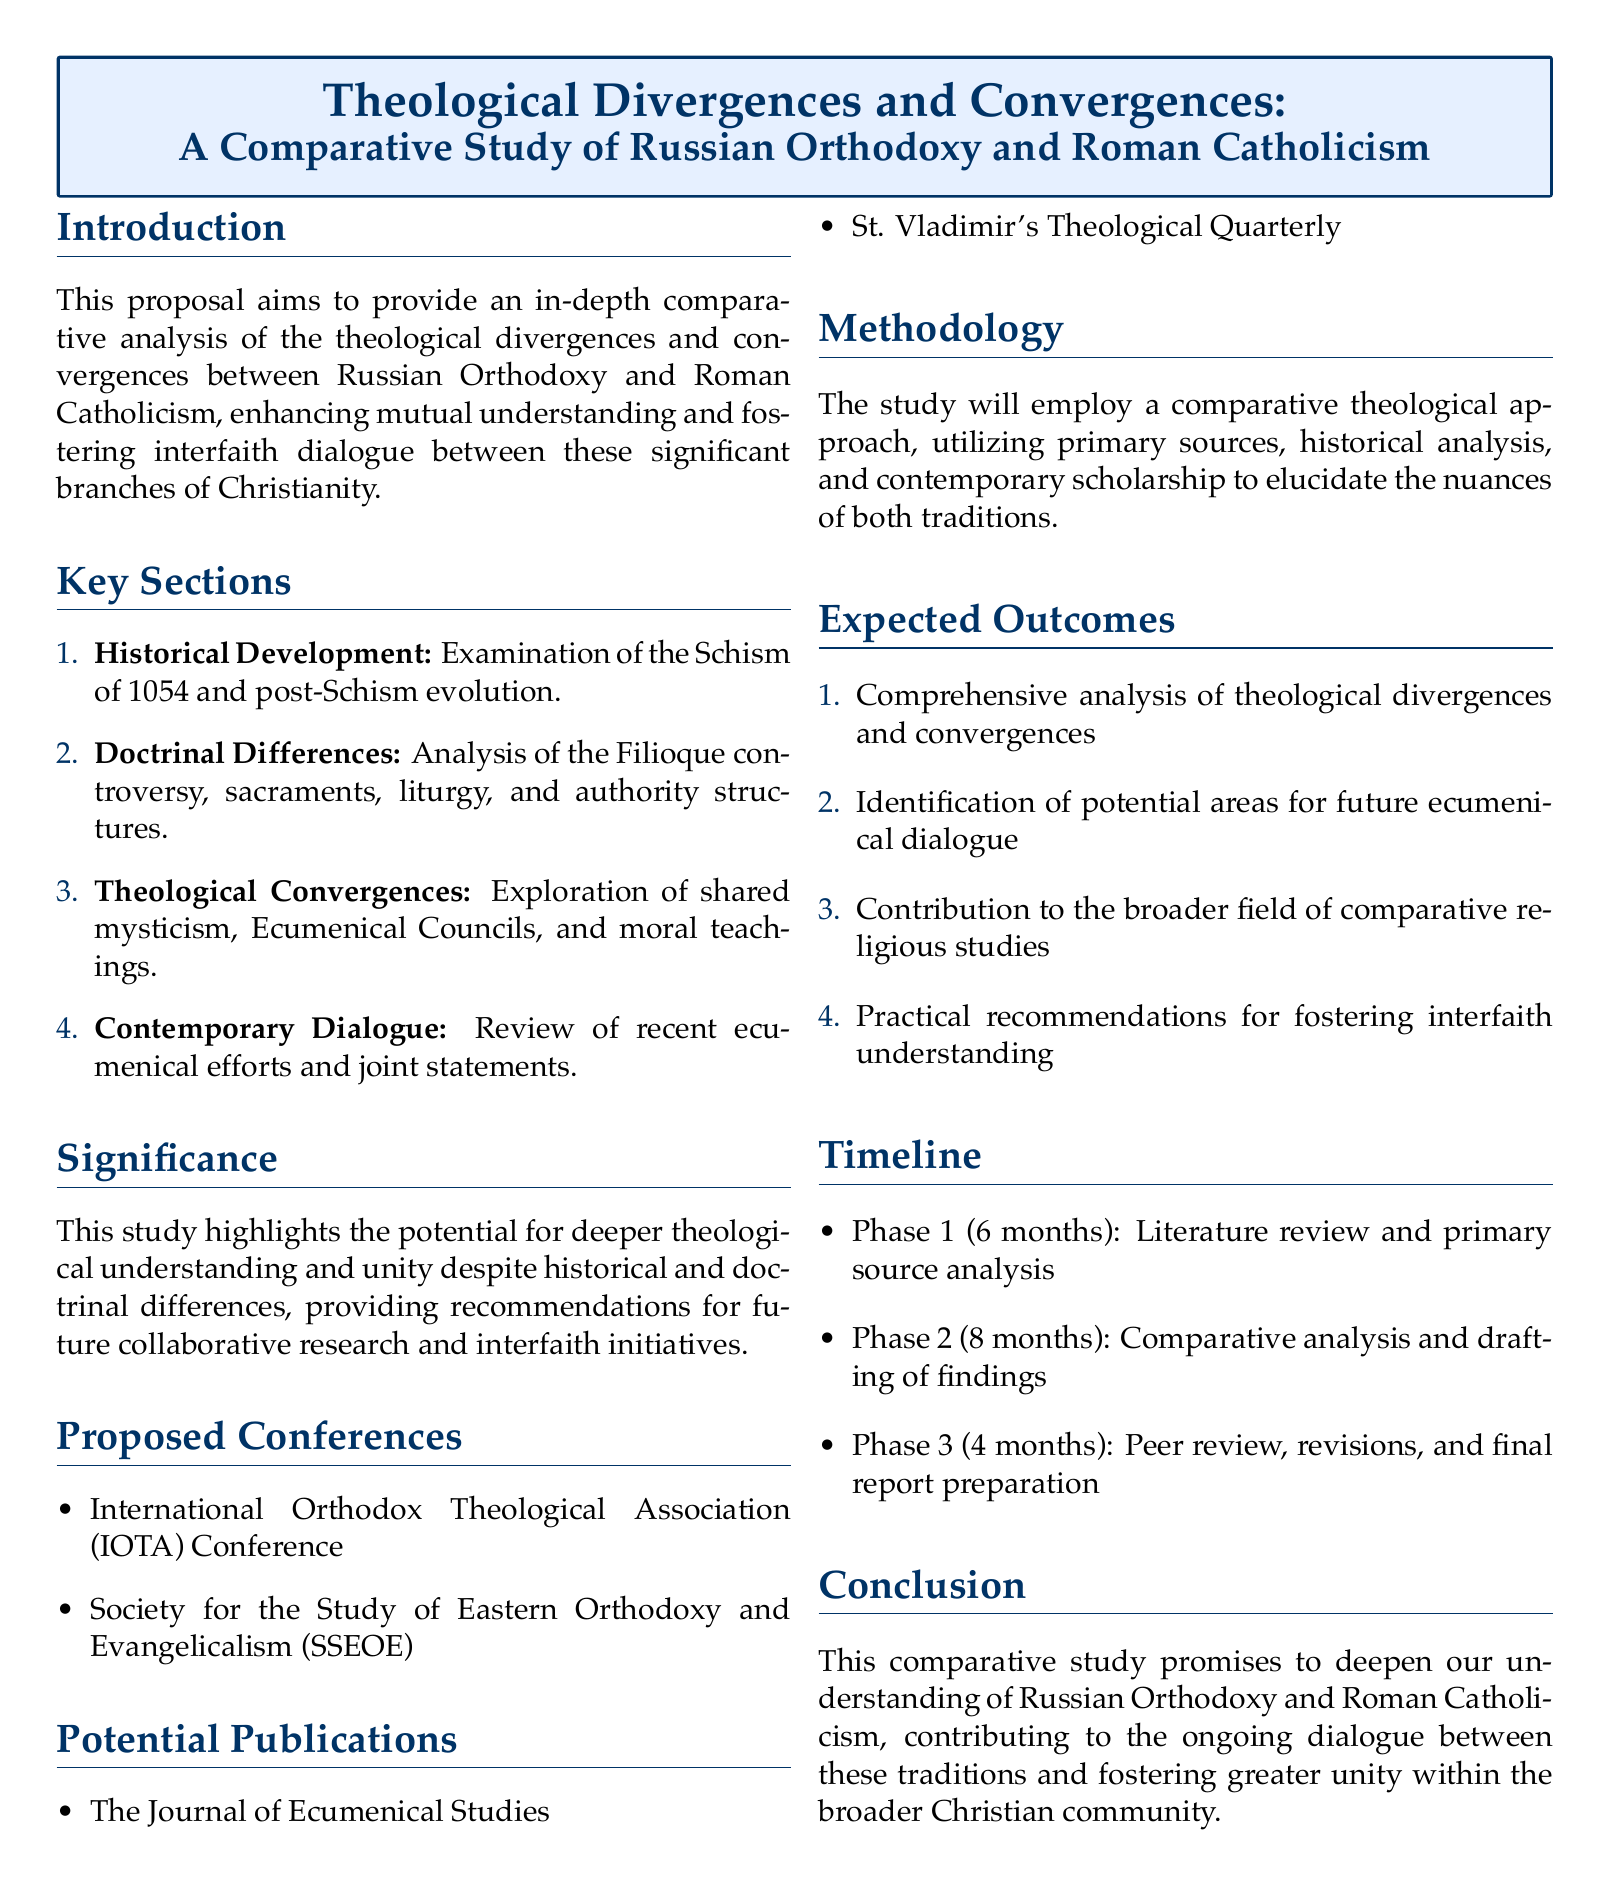What is the primary aim of the proposal? The proposal aims to provide an in-depth comparative analysis of the theological divergences and convergences between Russian Orthodoxy and Roman Catholicism.
Answer: In-depth comparative analysis What event is examined in the Historical Development section? The Historical Development section examines the Schism of 1054 and post-Schism evolution.
Answer: Schism of 1054 How many key sections are outlined in the document? The document outlines four key sections focused on comparative analysis.
Answer: Four What does the proposed methodology utilize? The proposed methodology utilizes primary sources, historical analysis, and contemporary scholarship.
Answer: Primary sources, historical analysis, and contemporary scholarship Name one proposed conference mentioned in the document. The document mentions the International Orthodox Theological Association (IOTA) Conference as one proposed conference.
Answer: International Orthodox Theological Association Conference What is one expected outcome of the study? One expected outcome of the study is a comprehensive analysis of theological divergences and convergences.
Answer: Comprehensive analysis of theological divergences and convergences What is the timeline for Phase 2 of the study? Phase 2 of the study is scheduled to take 8 months for comparative analysis and drafting of findings.
Answer: 8 months Which journal is listed as a potential publication? The document lists The Journal of Ecumenical Studies as a potential publication.
Answer: The Journal of Ecumenical Studies What is the significance of the study according to the proposal? The significance of the study highlights the potential for deeper theological understanding and unity despite historical and doctrinal differences.
Answer: Deeper theological understanding and unity 